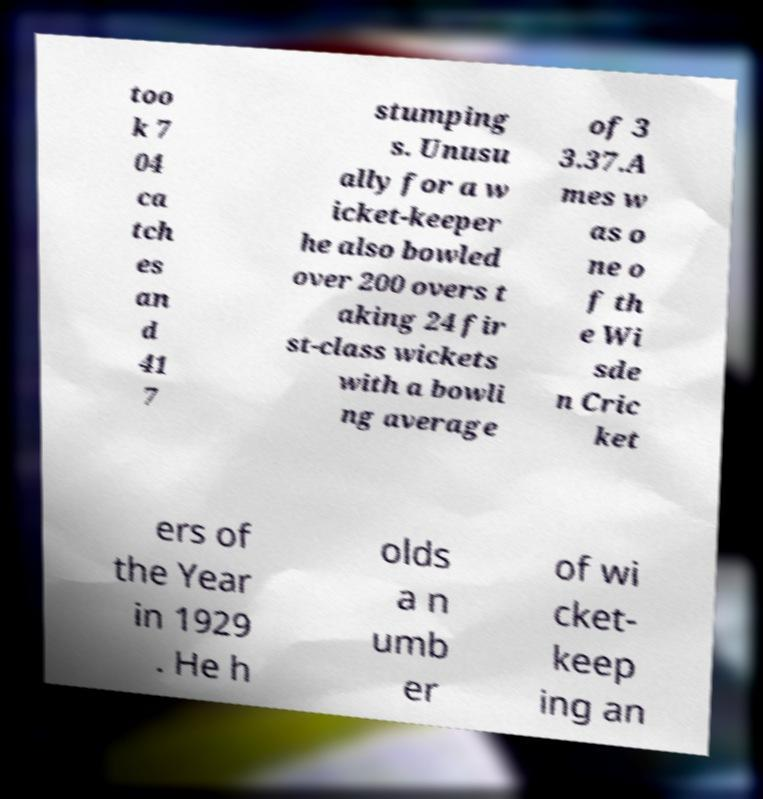Can you accurately transcribe the text from the provided image for me? too k 7 04 ca tch es an d 41 7 stumping s. Unusu ally for a w icket-keeper he also bowled over 200 overs t aking 24 fir st-class wickets with a bowli ng average of 3 3.37.A mes w as o ne o f th e Wi sde n Cric ket ers of the Year in 1929 . He h olds a n umb er of wi cket- keep ing an 